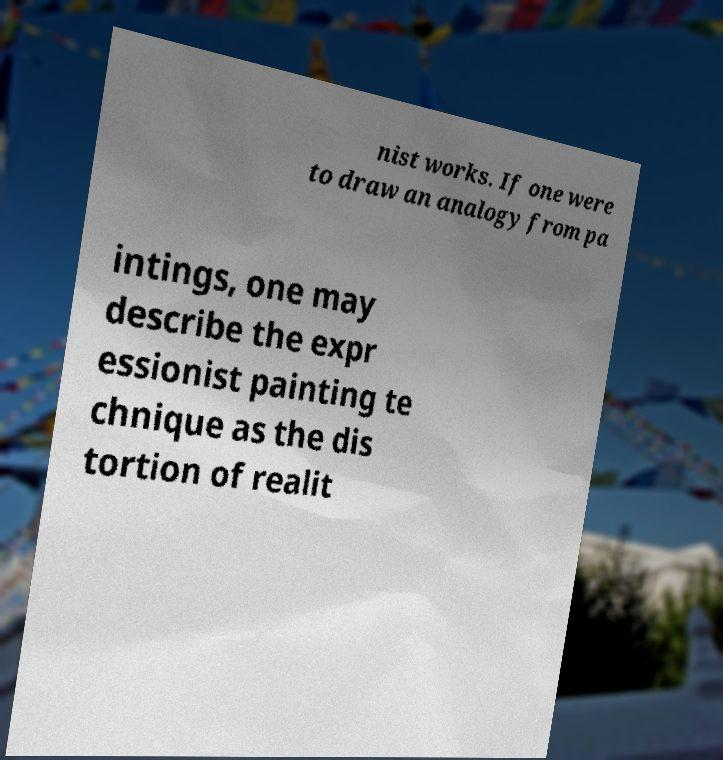Could you assist in decoding the text presented in this image and type it out clearly? nist works. If one were to draw an analogy from pa intings, one may describe the expr essionist painting te chnique as the dis tortion of realit 